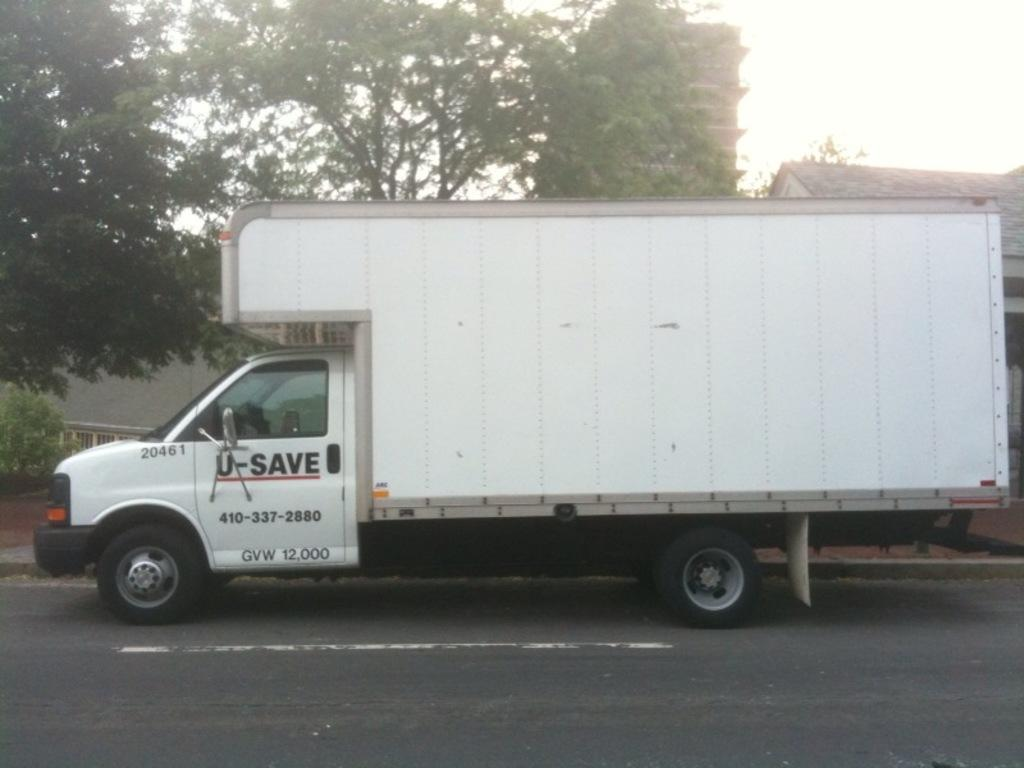What is happening in the foreground of the image? There is a vehicle moving on the road in the foreground of the image. What can be seen in the background of the image? There are trees, buildings, and the sky visible in the background of the image. What type of bait is being used to catch fish in the image? There is no fishing or bait present in the image; it features a vehicle moving on the road and a background with trees, buildings, and the sky. 